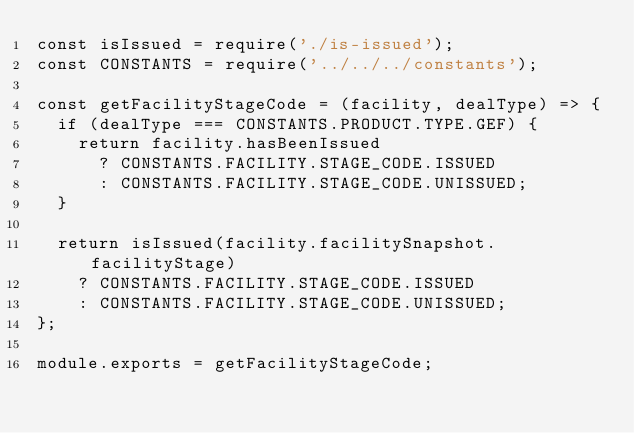Convert code to text. <code><loc_0><loc_0><loc_500><loc_500><_JavaScript_>const isIssued = require('./is-issued');
const CONSTANTS = require('../../../constants');

const getFacilityStageCode = (facility, dealType) => {
  if (dealType === CONSTANTS.PRODUCT.TYPE.GEF) {
    return facility.hasBeenIssued
      ? CONSTANTS.FACILITY.STAGE_CODE.ISSUED
      : CONSTANTS.FACILITY.STAGE_CODE.UNISSUED;
  }

  return isIssued(facility.facilitySnapshot.facilityStage)
    ? CONSTANTS.FACILITY.STAGE_CODE.ISSUED
    : CONSTANTS.FACILITY.STAGE_CODE.UNISSUED;
};

module.exports = getFacilityStageCode;
</code> 